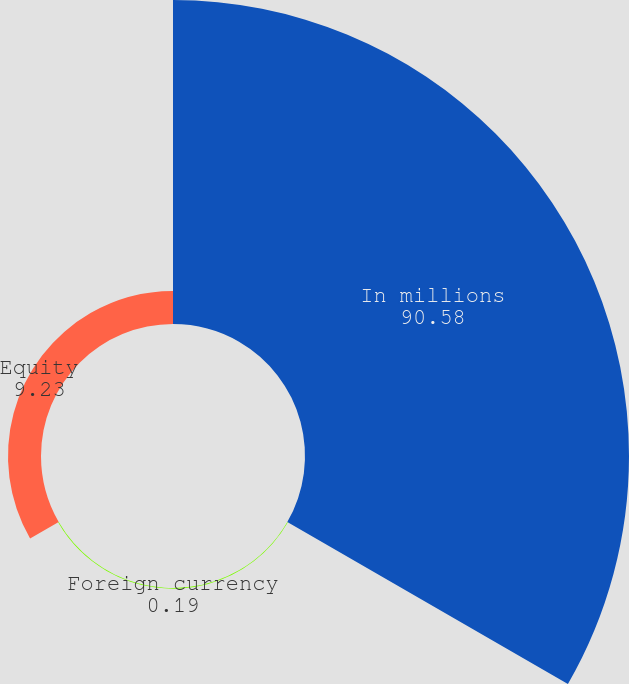<chart> <loc_0><loc_0><loc_500><loc_500><pie_chart><fcel>In millions<fcel>Foreign currency<fcel>Equity<nl><fcel>90.58%<fcel>0.19%<fcel>9.23%<nl></chart> 